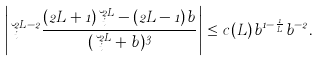Convert formula to latex. <formula><loc_0><loc_0><loc_500><loc_500>\left | \lambda _ { i } ^ { 2 L - 2 } \frac { ( 2 L + 1 ) \lambda _ { i } ^ { 2 L } - ( 2 L - 1 ) b } { ( \lambda _ { i } ^ { 2 L } + b ) ^ { 3 } } \right | \leq c ( L ) b ^ { 1 - \frac { 1 } { L } } b ^ { - 2 } .</formula> 